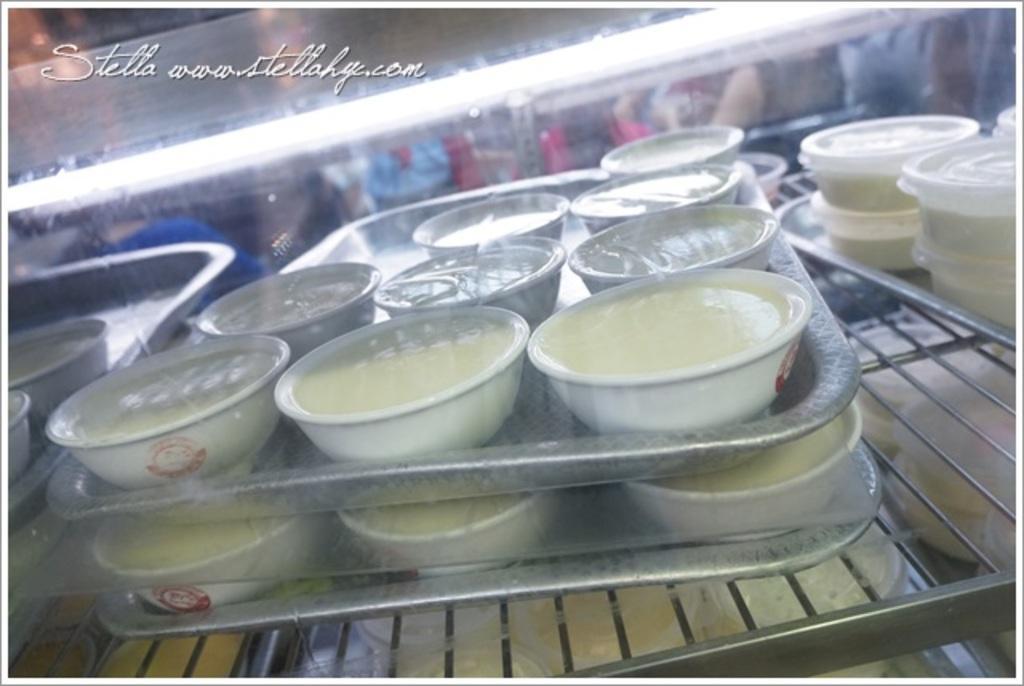Could you give a brief overview of what you see in this image? In the center of this picture we can see the trays containing the bowls and boxes of food items. In the foreground we can see the metal rods. In the background we can see the light and some other objects. In the top left corner we can see the text on the image. 